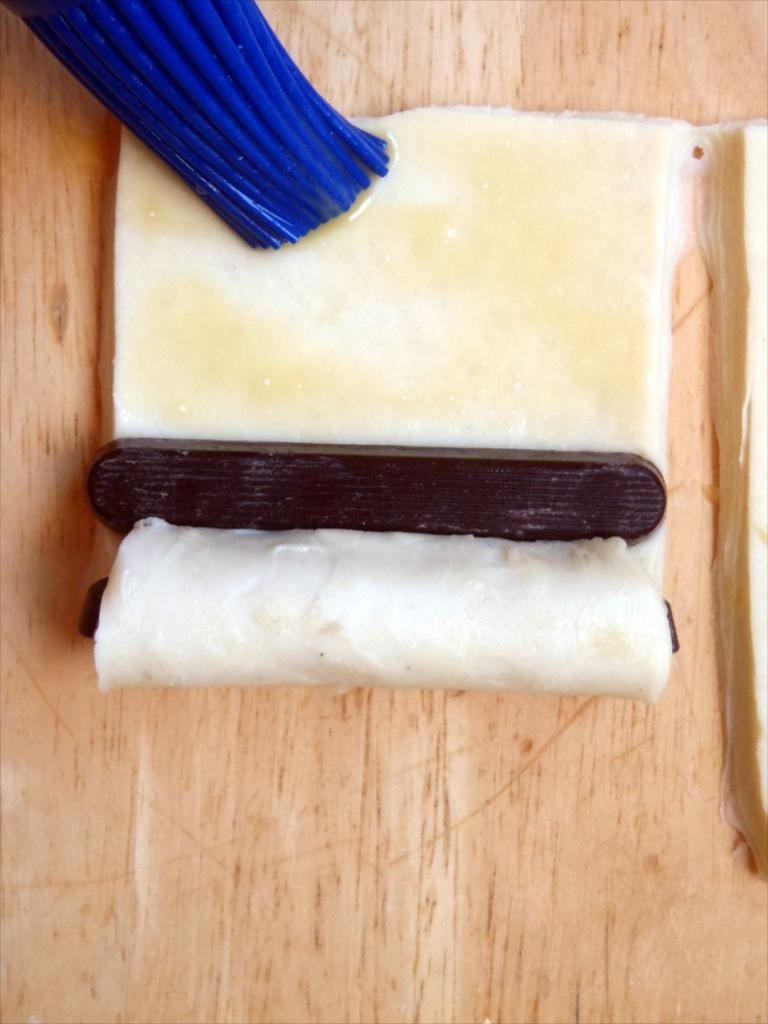What is the main object in the image? There is a table in the image. What can be found on the table? There are food items on the table. Is there any specific item related to painting or art in the image? Yes, there is a blue color brush in the image. How many birds are sitting on the table in the image? There are no birds present in the image. What does the aunt say about the food on the table in the image? There is no mention of an aunt or any dialogue in the image. 